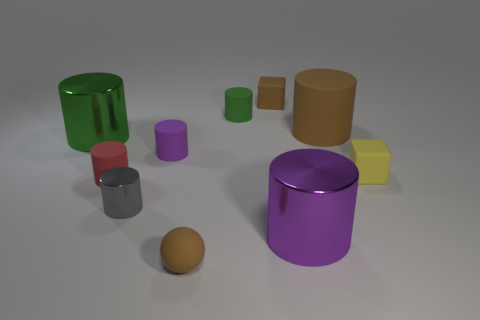Subtract 4 cylinders. How many cylinders are left? 3 Subtract all red cylinders. How many cylinders are left? 6 Subtract all gray shiny cylinders. How many cylinders are left? 6 Subtract all yellow cylinders. Subtract all blue blocks. How many cylinders are left? 7 Subtract all balls. How many objects are left? 9 Subtract all gray metallic objects. Subtract all large purple metal cylinders. How many objects are left? 8 Add 6 small shiny things. How many small shiny things are left? 7 Add 9 matte balls. How many matte balls exist? 10 Subtract 0 yellow cylinders. How many objects are left? 10 